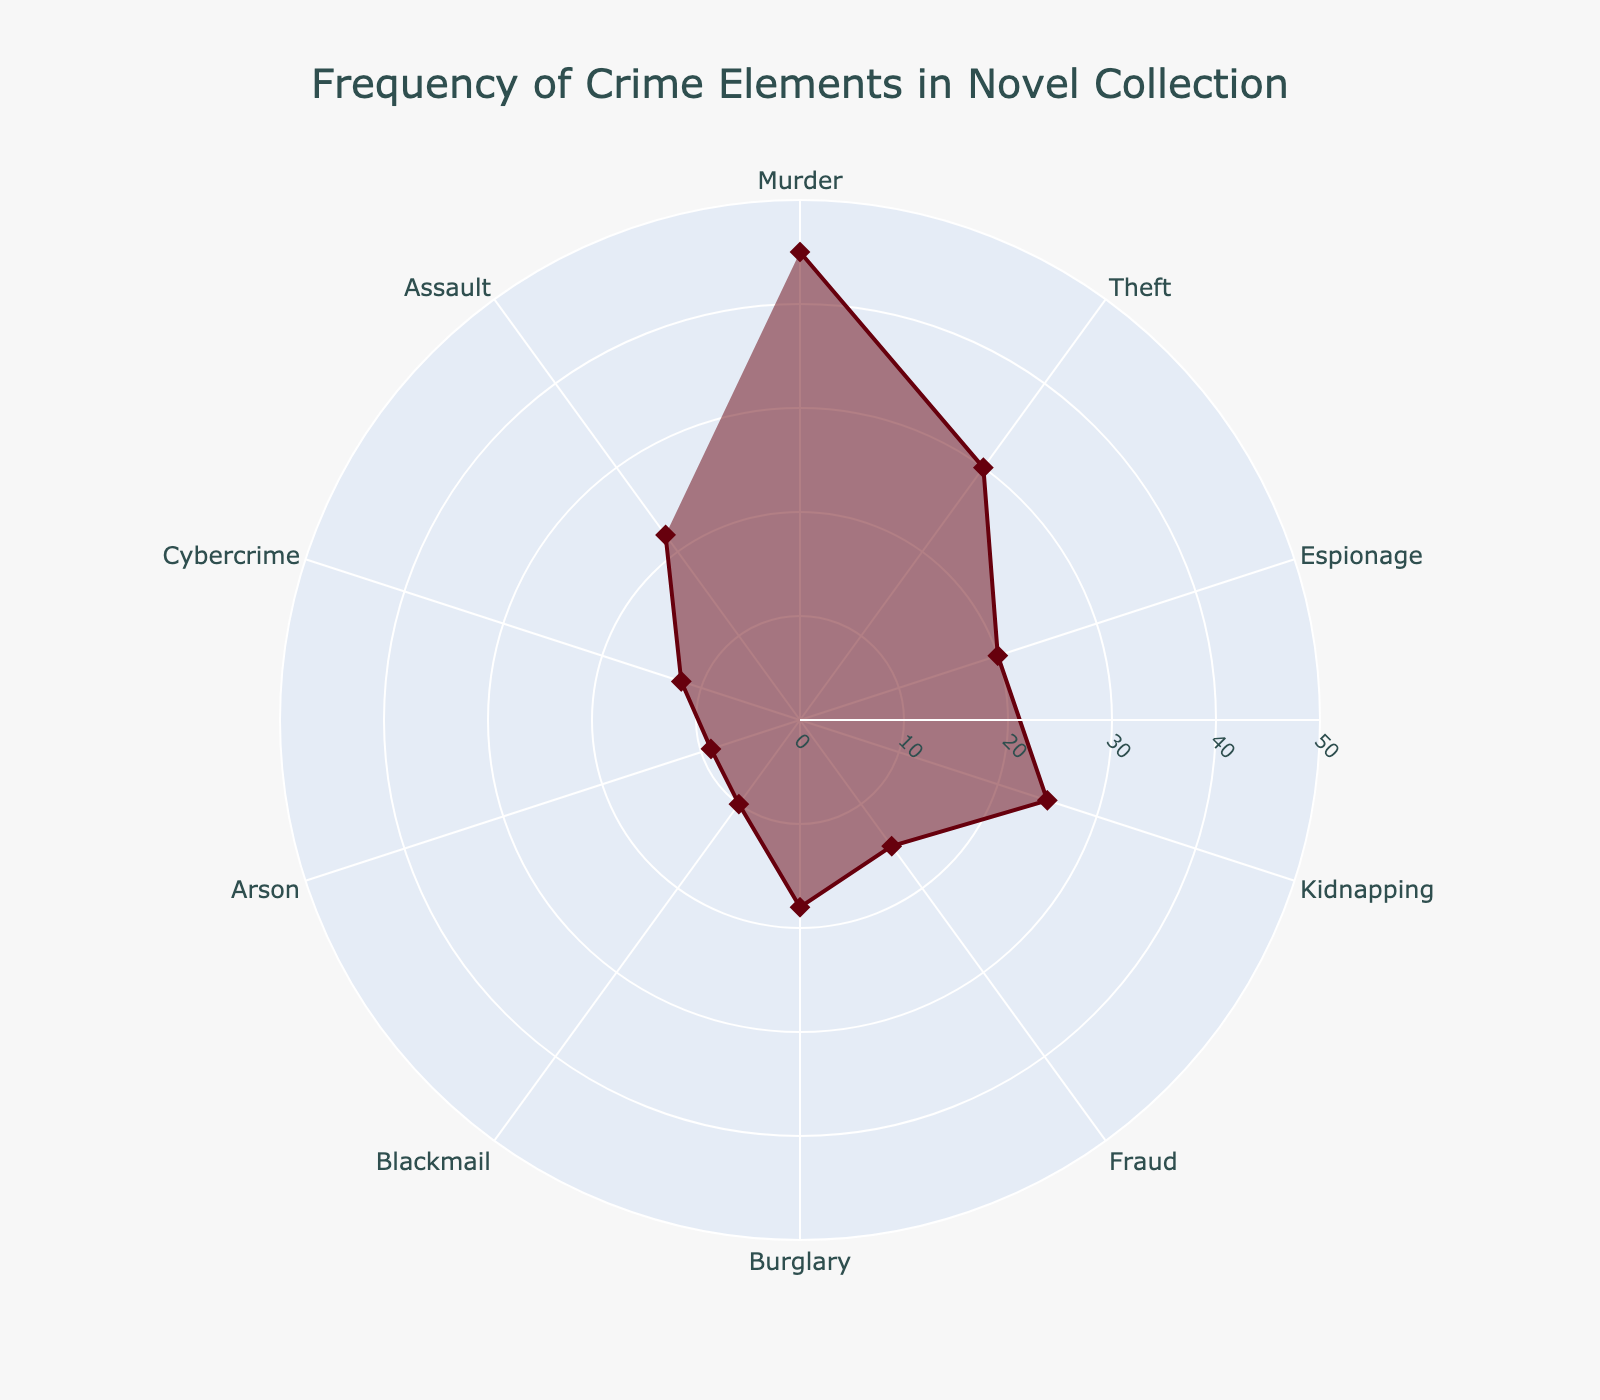What's the title of the radar chart? The title is displayed prominently at the top of the radar chart. It helps the viewer understand what the chart is about.
Answer: Frequency of Crime Elements in Novel Collection What crime element has the highest frequency? By looking at the outermost point on the radar chart, we can identify the crime element with the highest occurrence.
Answer: Murder Which crime element has the lowest frequency? Locate the innermost point on the radar chart to find the crime element with the least occurrences.
Answer: Arson How many occurrences of Theft are there in the collection? Find the point associated with Theft on the chart and read the corresponding value.
Answer: 30 What's the difference in frequency between Murder and Espionage? Find the values for Murder (45) and Espionage (20), then subtract the smaller from the larger (45 - 20).
Answer: 25 Which crime element has more occurrences: Kidnapping or Cybercrime? Compare the points for Kidnapping (25) and Cybercrime (12) and see which one is higher.
Answer: Kidnapping What is the average number of occurrences for all crime elements? Sum up all the values and divide by the number of crime elements. (45+30+20+25+15+18+10+9+12+22=206, 206 / 10).
Answer: 20.6 How does the frequency of Fraud compare to Assault? Compare the value for Fraud (15) to the value for Assault (22). Note which is higher.
Answer: Assault Are there any crime elements with the same frequency? Scan the chart to identify any points that have the same radial length.
Answer: No Which has a higher frequency: Burglary or Blackmail? Look at the values for Burglary (18) and Blackmail (10) and compare them.
Answer: Burglary 